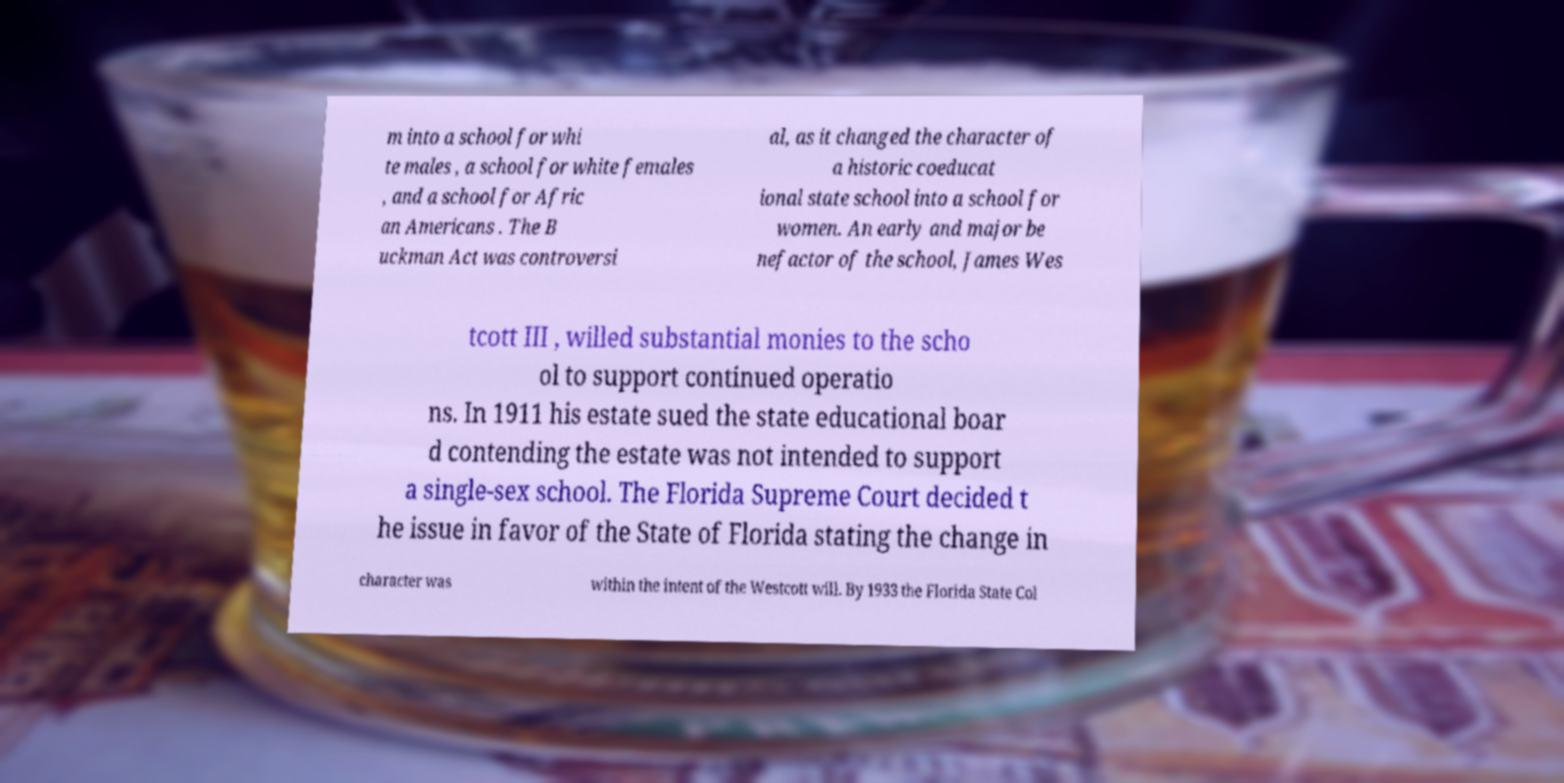I need the written content from this picture converted into text. Can you do that? m into a school for whi te males , a school for white females , and a school for Afric an Americans . The B uckman Act was controversi al, as it changed the character of a historic coeducat ional state school into a school for women. An early and major be nefactor of the school, James Wes tcott III , willed substantial monies to the scho ol to support continued operatio ns. In 1911 his estate sued the state educational boar d contending the estate was not intended to support a single-sex school. The Florida Supreme Court decided t he issue in favor of the State of Florida stating the change in character was within the intent of the Westcott will. By 1933 the Florida State Col 